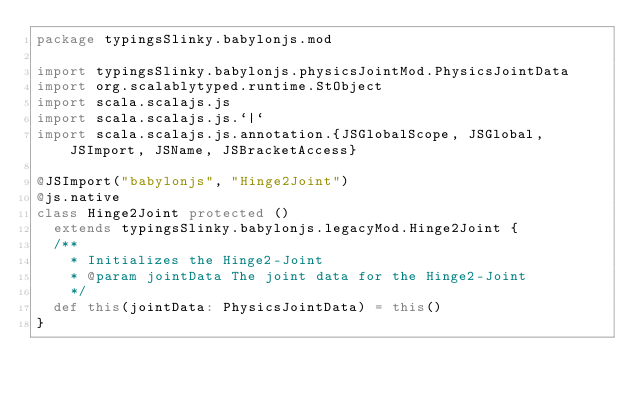Convert code to text. <code><loc_0><loc_0><loc_500><loc_500><_Scala_>package typingsSlinky.babylonjs.mod

import typingsSlinky.babylonjs.physicsJointMod.PhysicsJointData
import org.scalablytyped.runtime.StObject
import scala.scalajs.js
import scala.scalajs.js.`|`
import scala.scalajs.js.annotation.{JSGlobalScope, JSGlobal, JSImport, JSName, JSBracketAccess}

@JSImport("babylonjs", "Hinge2Joint")
@js.native
class Hinge2Joint protected ()
  extends typingsSlinky.babylonjs.legacyMod.Hinge2Joint {
  /**
    * Initializes the Hinge2-Joint
    * @param jointData The joint data for the Hinge2-Joint
    */
  def this(jointData: PhysicsJointData) = this()
}
</code> 